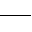Convert formula to latex. <formula><loc_0><loc_0><loc_500><loc_500>\_</formula> 